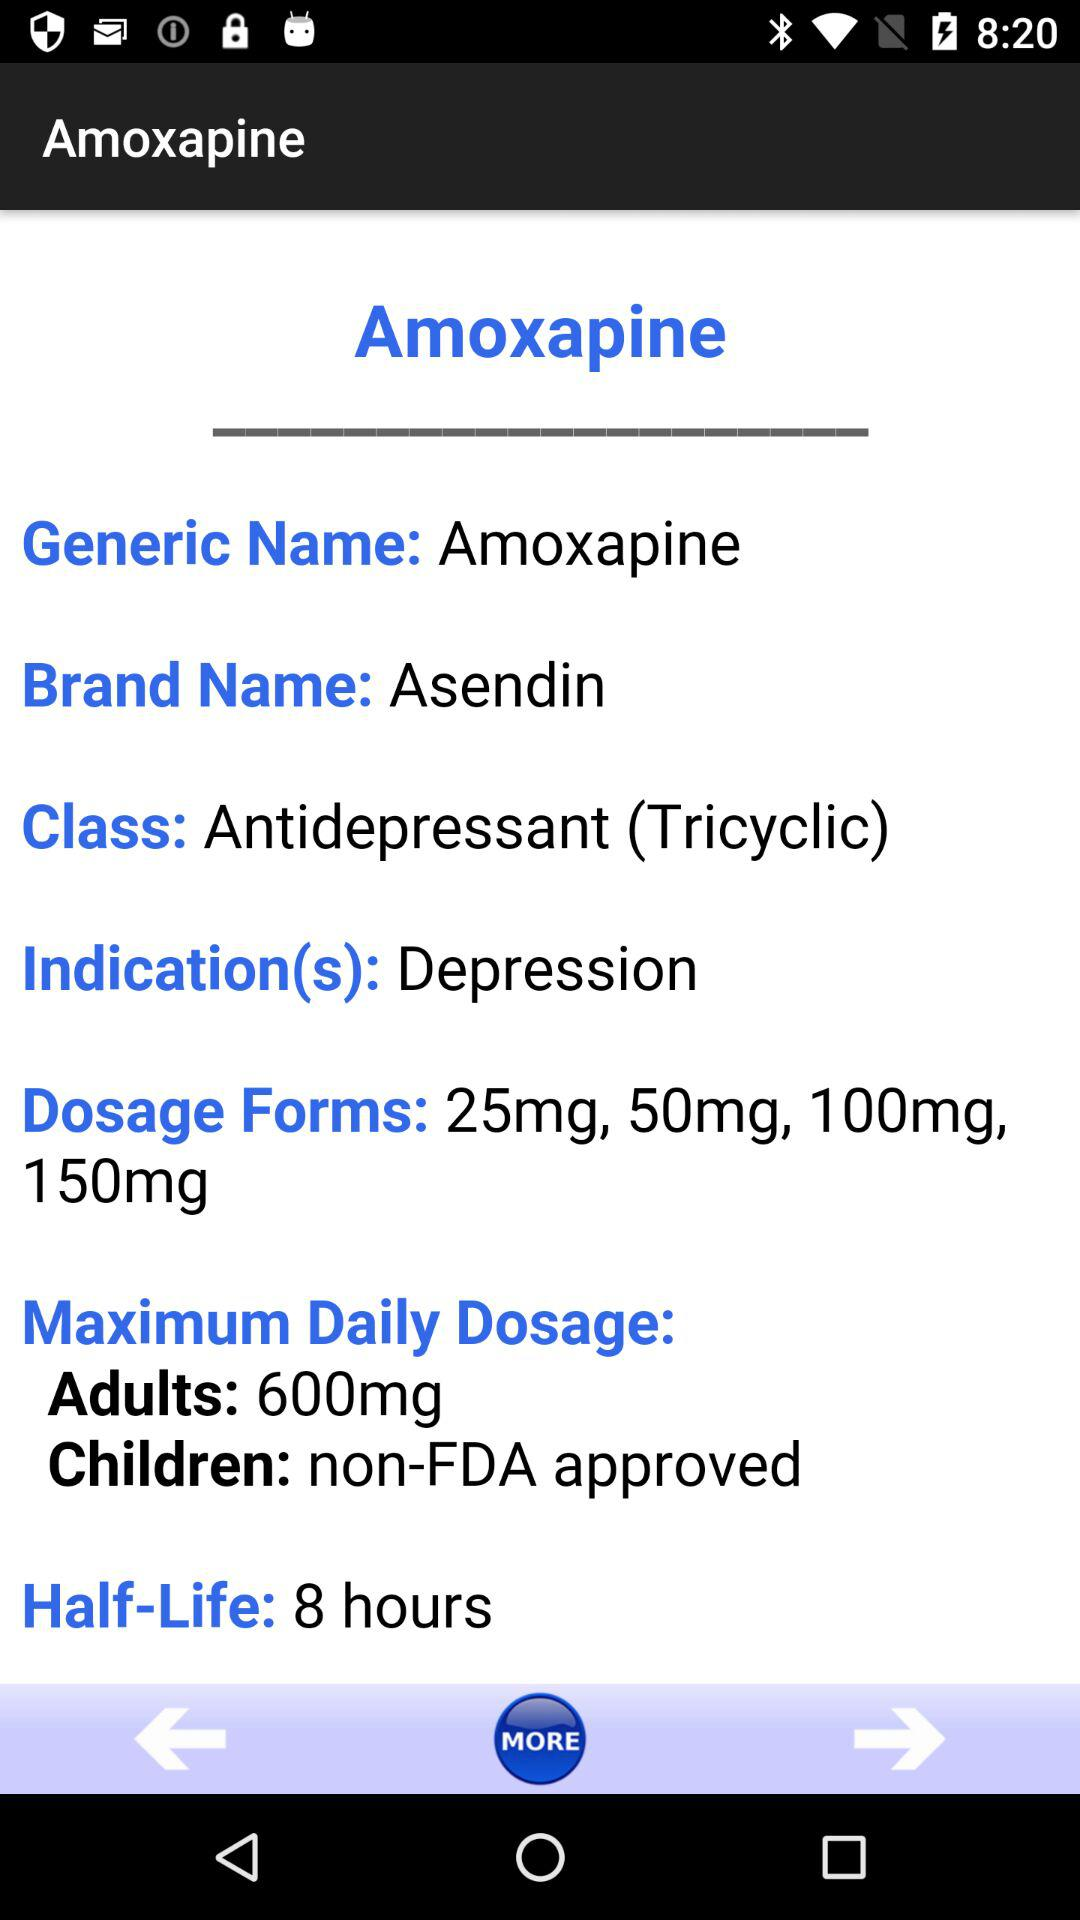What is the maximum daily dose for adults? The maximum daily dose for adults is 600 mg. 